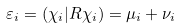<formula> <loc_0><loc_0><loc_500><loc_500>\varepsilon _ { i } = ( \chi _ { i } | R \chi _ { i } ) = \mu _ { i } + \nu _ { i }</formula> 